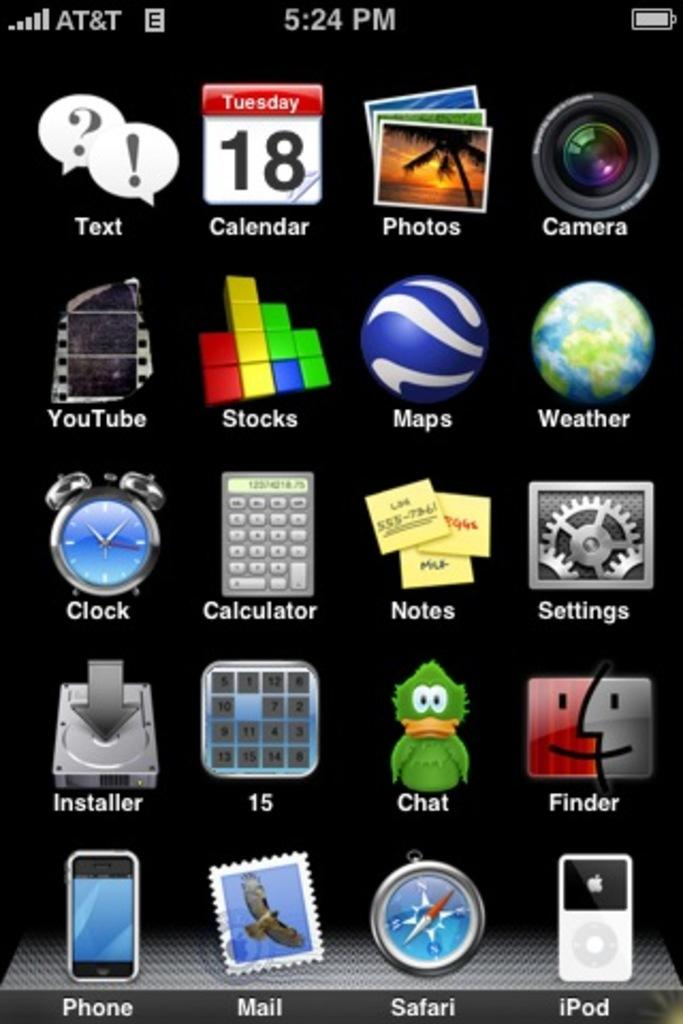What type of image is shown in the screenshot? The image is a screenshot. What can be seen in the screenshot? There are apps visible in the screenshot. What type of frame is used to display the apps in the screenshot? The screenshot does not show a frame; it is a digital image of apps on a device. What is the mist like in the screenshot? There is no mist present in the screenshot; it is a digital image of apps on a device. 